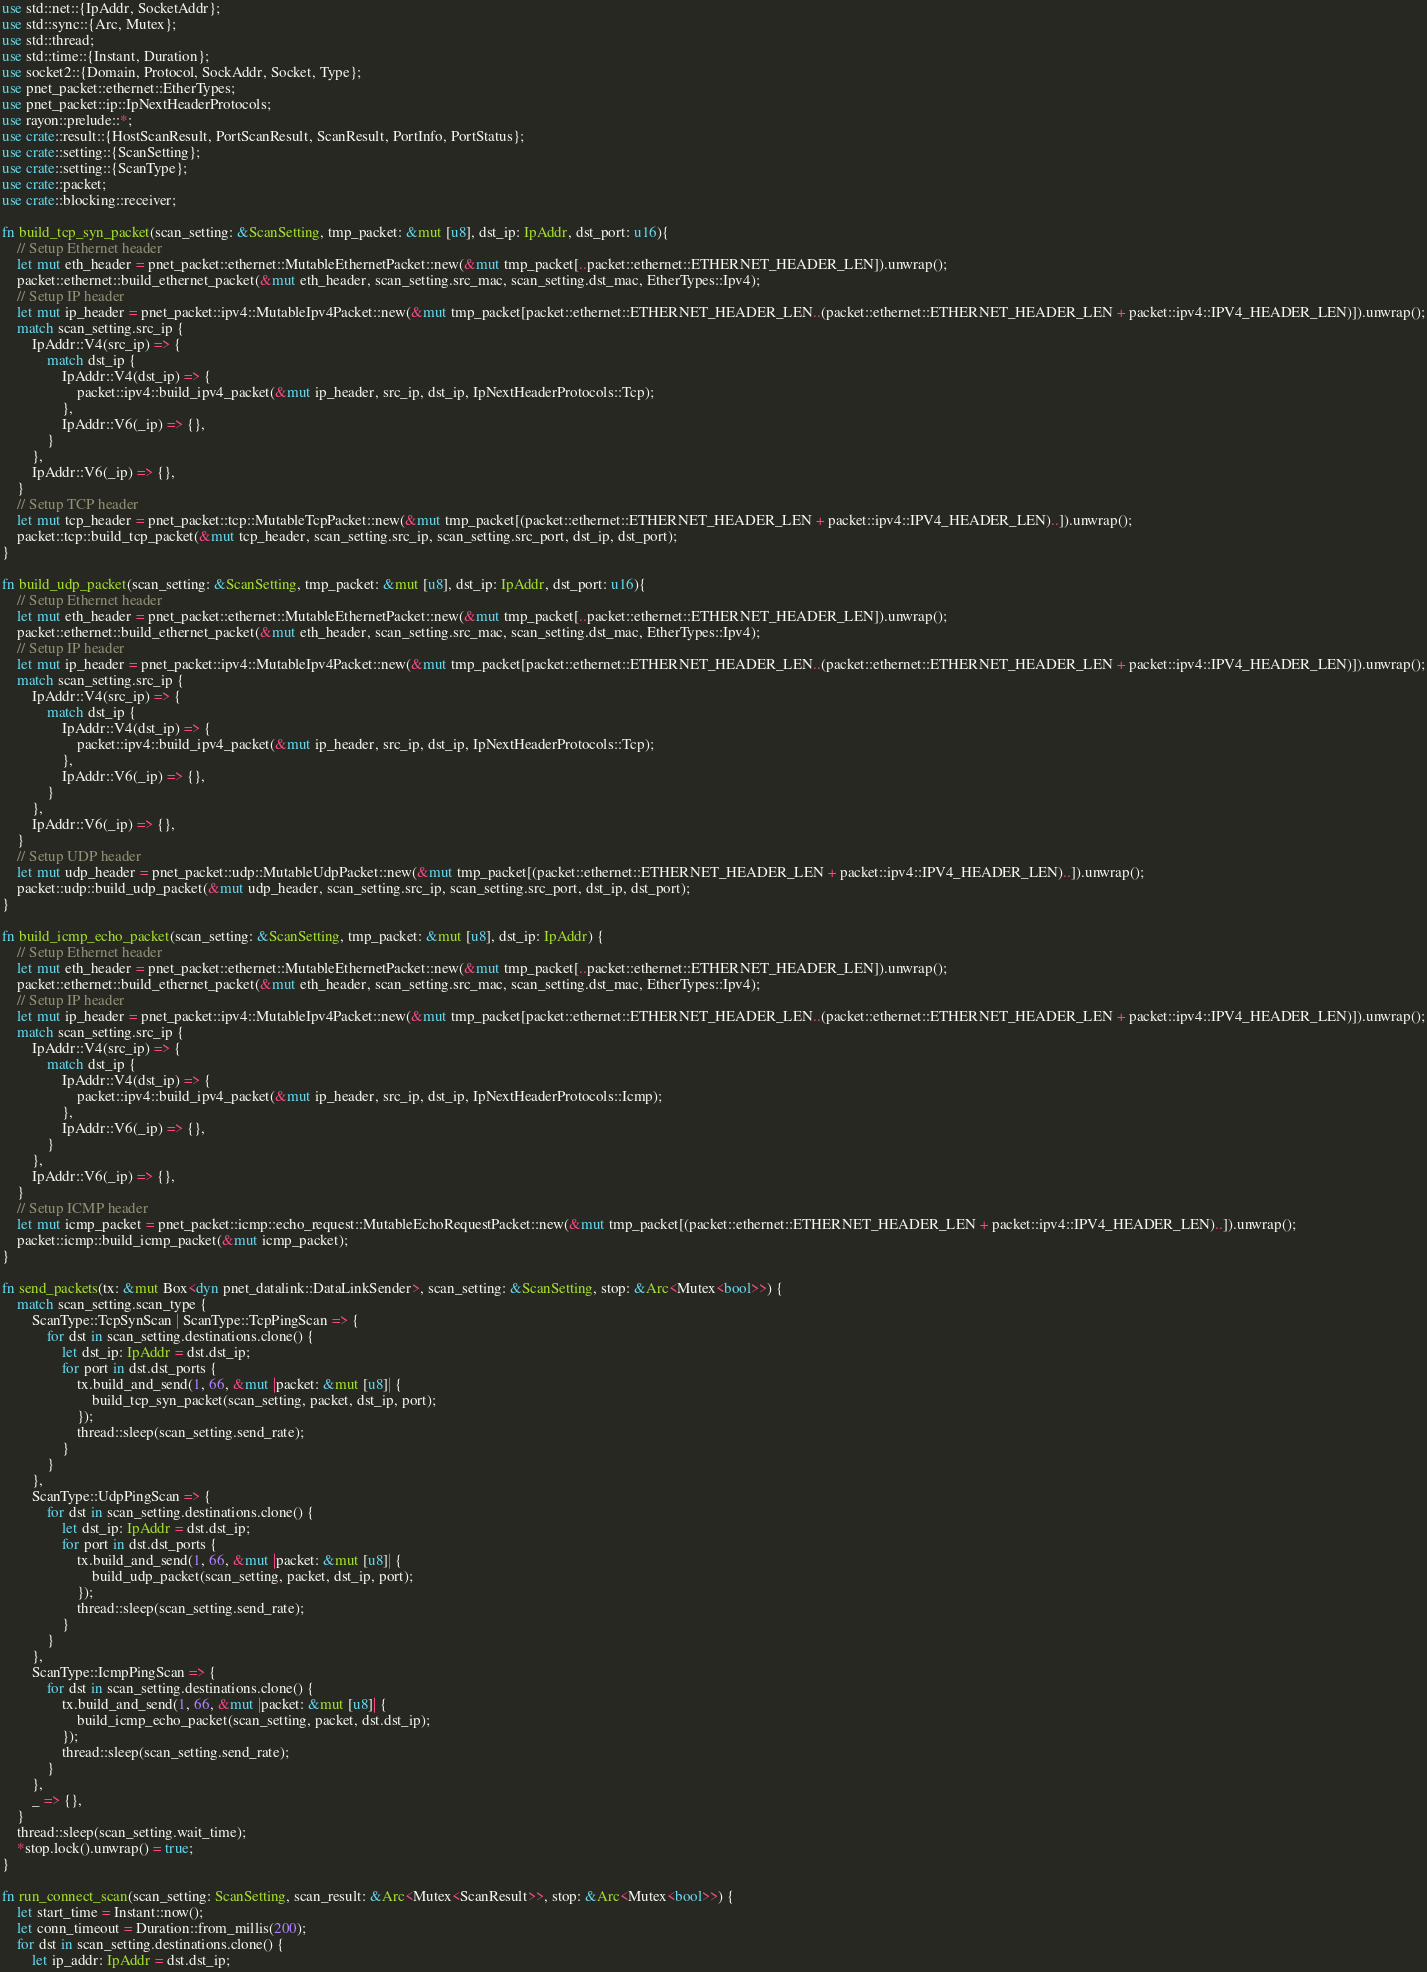Convert code to text. <code><loc_0><loc_0><loc_500><loc_500><_Rust_>use std::net::{IpAddr, SocketAddr};
use std::sync::{Arc, Mutex};
use std::thread;
use std::time::{Instant, Duration};
use socket2::{Domain, Protocol, SockAddr, Socket, Type};
use pnet_packet::ethernet::EtherTypes;
use pnet_packet::ip::IpNextHeaderProtocols;
use rayon::prelude::*;
use crate::result::{HostScanResult, PortScanResult, ScanResult, PortInfo, PortStatus};
use crate::setting::{ScanSetting};
use crate::setting::{ScanType};
use crate::packet;
use crate::blocking::receiver;

fn build_tcp_syn_packet(scan_setting: &ScanSetting, tmp_packet: &mut [u8], dst_ip: IpAddr, dst_port: u16){
    // Setup Ethernet header
    let mut eth_header = pnet_packet::ethernet::MutableEthernetPacket::new(&mut tmp_packet[..packet::ethernet::ETHERNET_HEADER_LEN]).unwrap();
    packet::ethernet::build_ethernet_packet(&mut eth_header, scan_setting.src_mac, scan_setting.dst_mac, EtherTypes::Ipv4);
    // Setup IP header
    let mut ip_header = pnet_packet::ipv4::MutableIpv4Packet::new(&mut tmp_packet[packet::ethernet::ETHERNET_HEADER_LEN..(packet::ethernet::ETHERNET_HEADER_LEN + packet::ipv4::IPV4_HEADER_LEN)]).unwrap();
    match scan_setting.src_ip {
        IpAddr::V4(src_ip) => {
            match dst_ip {
                IpAddr::V4(dst_ip) => {
                    packet::ipv4::build_ipv4_packet(&mut ip_header, src_ip, dst_ip, IpNextHeaderProtocols::Tcp);
                },
                IpAddr::V6(_ip) => {},
            }
        },
        IpAddr::V6(_ip) => {},
    }
    // Setup TCP header
    let mut tcp_header = pnet_packet::tcp::MutableTcpPacket::new(&mut tmp_packet[(packet::ethernet::ETHERNET_HEADER_LEN + packet::ipv4::IPV4_HEADER_LEN)..]).unwrap();
    packet::tcp::build_tcp_packet(&mut tcp_header, scan_setting.src_ip, scan_setting.src_port, dst_ip, dst_port);
}

fn build_udp_packet(scan_setting: &ScanSetting, tmp_packet: &mut [u8], dst_ip: IpAddr, dst_port: u16){
    // Setup Ethernet header
    let mut eth_header = pnet_packet::ethernet::MutableEthernetPacket::new(&mut tmp_packet[..packet::ethernet::ETHERNET_HEADER_LEN]).unwrap();
    packet::ethernet::build_ethernet_packet(&mut eth_header, scan_setting.src_mac, scan_setting.dst_mac, EtherTypes::Ipv4);
    // Setup IP header
    let mut ip_header = pnet_packet::ipv4::MutableIpv4Packet::new(&mut tmp_packet[packet::ethernet::ETHERNET_HEADER_LEN..(packet::ethernet::ETHERNET_HEADER_LEN + packet::ipv4::IPV4_HEADER_LEN)]).unwrap();
    match scan_setting.src_ip {
        IpAddr::V4(src_ip) => {
            match dst_ip {
                IpAddr::V4(dst_ip) => {
                    packet::ipv4::build_ipv4_packet(&mut ip_header, src_ip, dst_ip, IpNextHeaderProtocols::Tcp);
                },
                IpAddr::V6(_ip) => {},
            }
        },
        IpAddr::V6(_ip) => {},
    }
    // Setup UDP header
    let mut udp_header = pnet_packet::udp::MutableUdpPacket::new(&mut tmp_packet[(packet::ethernet::ETHERNET_HEADER_LEN + packet::ipv4::IPV4_HEADER_LEN)..]).unwrap();
    packet::udp::build_udp_packet(&mut udp_header, scan_setting.src_ip, scan_setting.src_port, dst_ip, dst_port);
}

fn build_icmp_echo_packet(scan_setting: &ScanSetting, tmp_packet: &mut [u8], dst_ip: IpAddr) {
    // Setup Ethernet header
    let mut eth_header = pnet_packet::ethernet::MutableEthernetPacket::new(&mut tmp_packet[..packet::ethernet::ETHERNET_HEADER_LEN]).unwrap();
    packet::ethernet::build_ethernet_packet(&mut eth_header, scan_setting.src_mac, scan_setting.dst_mac, EtherTypes::Ipv4);
    // Setup IP header
    let mut ip_header = pnet_packet::ipv4::MutableIpv4Packet::new(&mut tmp_packet[packet::ethernet::ETHERNET_HEADER_LEN..(packet::ethernet::ETHERNET_HEADER_LEN + packet::ipv4::IPV4_HEADER_LEN)]).unwrap();
    match scan_setting.src_ip {
        IpAddr::V4(src_ip) => {
            match dst_ip {
                IpAddr::V4(dst_ip) => {
                    packet::ipv4::build_ipv4_packet(&mut ip_header, src_ip, dst_ip, IpNextHeaderProtocols::Icmp);
                },
                IpAddr::V6(_ip) => {},
            }
        },
        IpAddr::V6(_ip) => {},
    }
    // Setup ICMP header
    let mut icmp_packet = pnet_packet::icmp::echo_request::MutableEchoRequestPacket::new(&mut tmp_packet[(packet::ethernet::ETHERNET_HEADER_LEN + packet::ipv4::IPV4_HEADER_LEN)..]).unwrap();
    packet::icmp::build_icmp_packet(&mut icmp_packet);
}

fn send_packets(tx: &mut Box<dyn pnet_datalink::DataLinkSender>, scan_setting: &ScanSetting, stop: &Arc<Mutex<bool>>) {
    match scan_setting.scan_type {
        ScanType::TcpSynScan | ScanType::TcpPingScan => {
            for dst in scan_setting.destinations.clone() {
                let dst_ip: IpAddr = dst.dst_ip;
                for port in dst.dst_ports {
                    tx.build_and_send(1, 66, &mut |packet: &mut [u8]| {
                        build_tcp_syn_packet(scan_setting, packet, dst_ip, port);
                    });
                    thread::sleep(scan_setting.send_rate);
                }
            }
        },
        ScanType::UdpPingScan => {
            for dst in scan_setting.destinations.clone() {
                let dst_ip: IpAddr = dst.dst_ip;
                for port in dst.dst_ports {
                    tx.build_and_send(1, 66, &mut |packet: &mut [u8]| {
                        build_udp_packet(scan_setting, packet, dst_ip, port);
                    });
                    thread::sleep(scan_setting.send_rate);
                }
            }
        },
        ScanType::IcmpPingScan => {
            for dst in scan_setting.destinations.clone() {
                tx.build_and_send(1, 66, &mut |packet: &mut [u8]| {
                    build_icmp_echo_packet(scan_setting, packet, dst.dst_ip);
                });
                thread::sleep(scan_setting.send_rate);
            }
        },
        _ => {},
    }
    thread::sleep(scan_setting.wait_time);
    *stop.lock().unwrap() = true;
}

fn run_connect_scan(scan_setting: ScanSetting, scan_result: &Arc<Mutex<ScanResult>>, stop: &Arc<Mutex<bool>>) {
    let start_time = Instant::now();
    let conn_timeout = Duration::from_millis(200);
    for dst in scan_setting.destinations.clone() {
        let ip_addr: IpAddr = dst.dst_ip;</code> 